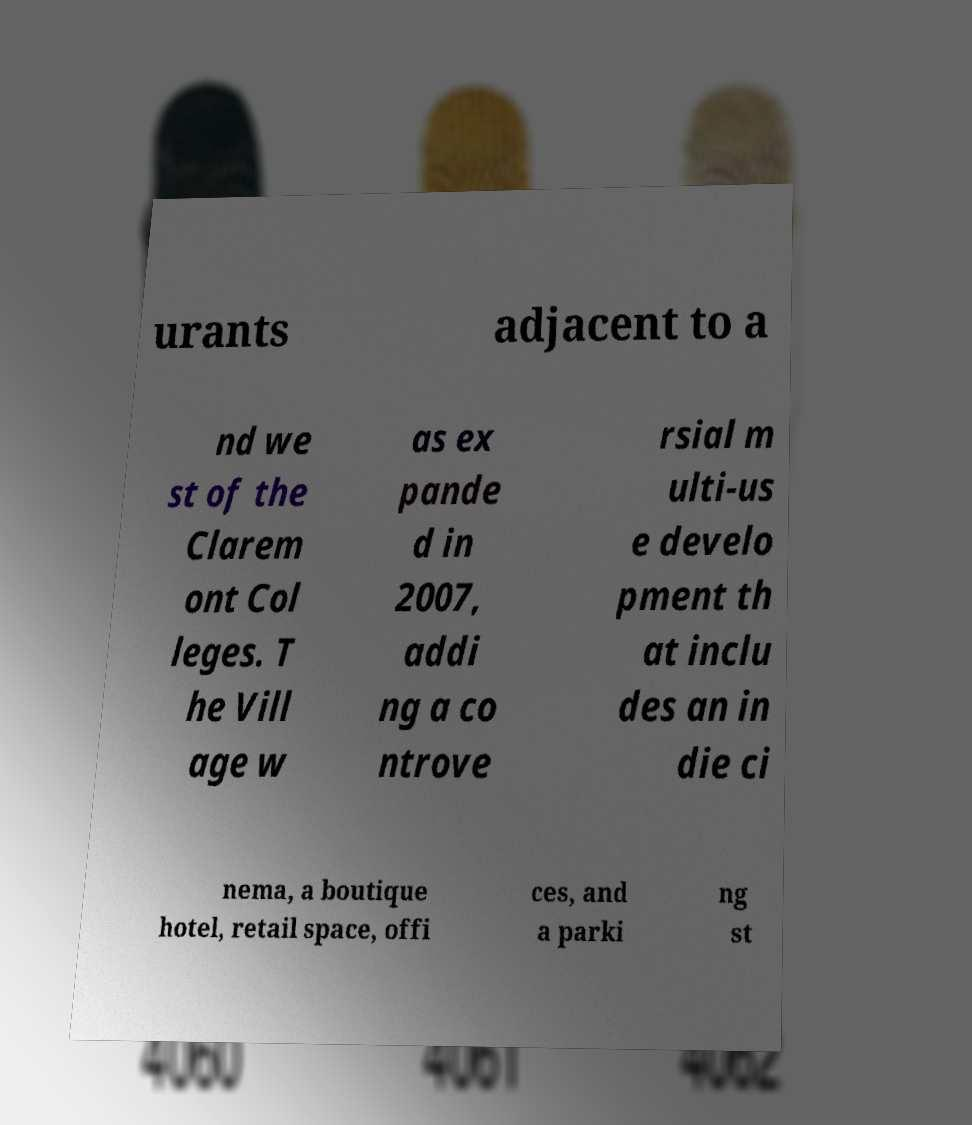I need the written content from this picture converted into text. Can you do that? urants adjacent to a nd we st of the Clarem ont Col leges. T he Vill age w as ex pande d in 2007, addi ng a co ntrove rsial m ulti-us e develo pment th at inclu des an in die ci nema, a boutique hotel, retail space, offi ces, and a parki ng st 